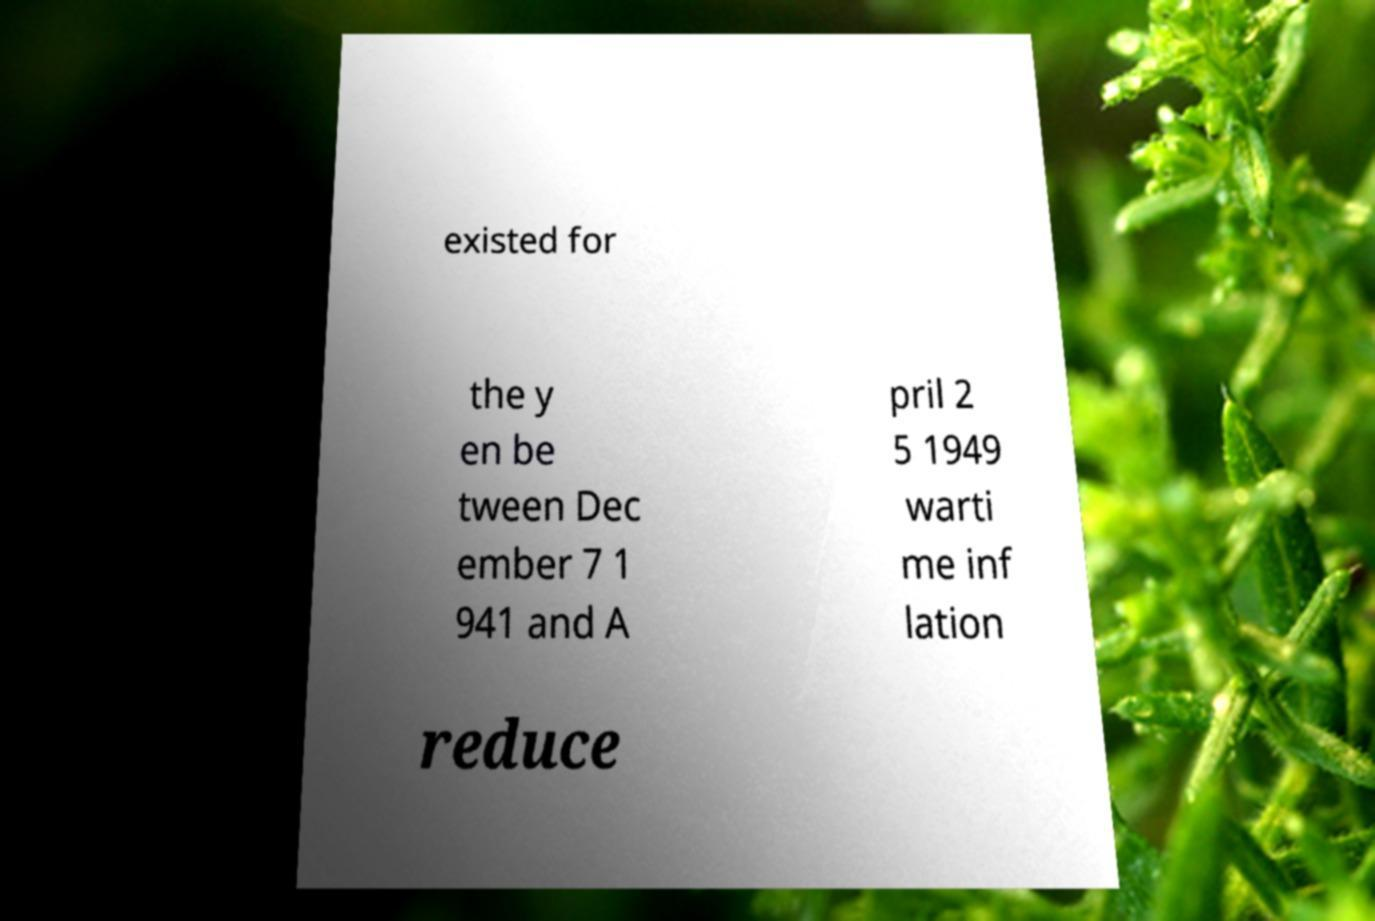For documentation purposes, I need the text within this image transcribed. Could you provide that? existed for the y en be tween Dec ember 7 1 941 and A pril 2 5 1949 warti me inf lation reduce 